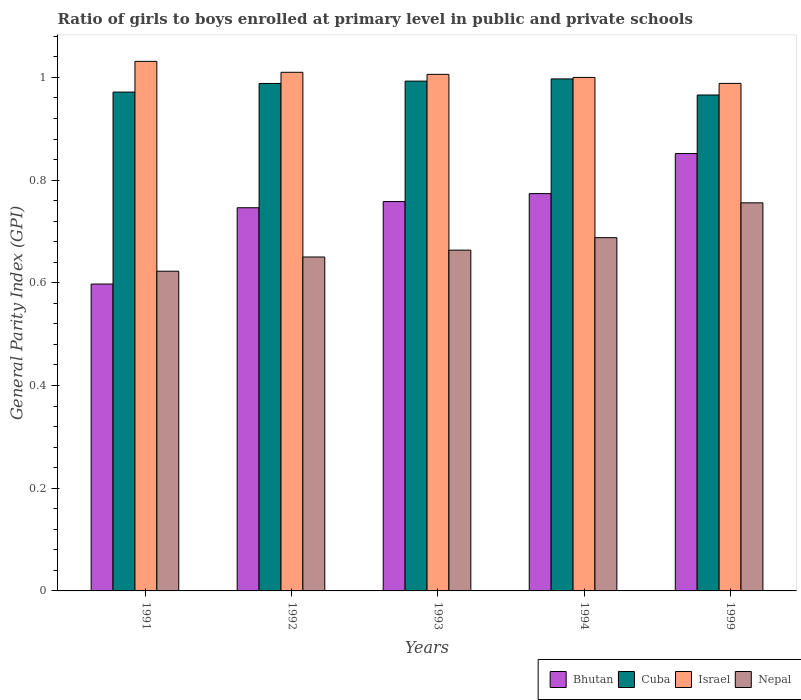How many groups of bars are there?
Your answer should be very brief. 5. Are the number of bars per tick equal to the number of legend labels?
Make the answer very short. Yes. Are the number of bars on each tick of the X-axis equal?
Offer a very short reply. Yes. What is the general parity index in Cuba in 1994?
Offer a very short reply. 1. Across all years, what is the maximum general parity index in Nepal?
Offer a terse response. 0.76. Across all years, what is the minimum general parity index in Nepal?
Provide a succinct answer. 0.62. What is the total general parity index in Nepal in the graph?
Provide a succinct answer. 3.38. What is the difference between the general parity index in Bhutan in 1992 and that in 1993?
Offer a very short reply. -0.01. What is the difference between the general parity index in Israel in 1993 and the general parity index in Nepal in 1994?
Make the answer very short. 0.32. What is the average general parity index in Bhutan per year?
Your response must be concise. 0.75. In the year 1994, what is the difference between the general parity index in Israel and general parity index in Nepal?
Give a very brief answer. 0.31. In how many years, is the general parity index in Israel greater than 0.9600000000000001?
Your answer should be very brief. 5. What is the ratio of the general parity index in Bhutan in 1991 to that in 1994?
Make the answer very short. 0.77. What is the difference between the highest and the second highest general parity index in Nepal?
Offer a very short reply. 0.07. What is the difference between the highest and the lowest general parity index in Israel?
Give a very brief answer. 0.04. In how many years, is the general parity index in Cuba greater than the average general parity index in Cuba taken over all years?
Provide a short and direct response. 3. What does the 4th bar from the left in 1991 represents?
Your answer should be very brief. Nepal. What does the 1st bar from the right in 1991 represents?
Your answer should be very brief. Nepal. Is it the case that in every year, the sum of the general parity index in Cuba and general parity index in Israel is greater than the general parity index in Nepal?
Make the answer very short. Yes. How many bars are there?
Offer a terse response. 20. Are all the bars in the graph horizontal?
Provide a short and direct response. No. How many years are there in the graph?
Keep it short and to the point. 5. Are the values on the major ticks of Y-axis written in scientific E-notation?
Provide a succinct answer. No. Does the graph contain grids?
Provide a short and direct response. No. How many legend labels are there?
Your response must be concise. 4. How are the legend labels stacked?
Give a very brief answer. Horizontal. What is the title of the graph?
Your answer should be very brief. Ratio of girls to boys enrolled at primary level in public and private schools. Does "San Marino" appear as one of the legend labels in the graph?
Offer a terse response. No. What is the label or title of the X-axis?
Offer a terse response. Years. What is the label or title of the Y-axis?
Your answer should be very brief. General Parity Index (GPI). What is the General Parity Index (GPI) of Bhutan in 1991?
Give a very brief answer. 0.6. What is the General Parity Index (GPI) in Cuba in 1991?
Offer a terse response. 0.97. What is the General Parity Index (GPI) in Israel in 1991?
Make the answer very short. 1.03. What is the General Parity Index (GPI) of Nepal in 1991?
Provide a short and direct response. 0.62. What is the General Parity Index (GPI) in Bhutan in 1992?
Provide a short and direct response. 0.75. What is the General Parity Index (GPI) of Cuba in 1992?
Provide a succinct answer. 0.99. What is the General Parity Index (GPI) in Israel in 1992?
Provide a short and direct response. 1.01. What is the General Parity Index (GPI) of Nepal in 1992?
Keep it short and to the point. 0.65. What is the General Parity Index (GPI) in Bhutan in 1993?
Provide a short and direct response. 0.76. What is the General Parity Index (GPI) in Cuba in 1993?
Your answer should be very brief. 0.99. What is the General Parity Index (GPI) in Israel in 1993?
Give a very brief answer. 1.01. What is the General Parity Index (GPI) of Nepal in 1993?
Provide a short and direct response. 0.66. What is the General Parity Index (GPI) of Bhutan in 1994?
Your answer should be very brief. 0.77. What is the General Parity Index (GPI) of Cuba in 1994?
Your answer should be very brief. 1. What is the General Parity Index (GPI) of Israel in 1994?
Ensure brevity in your answer.  1. What is the General Parity Index (GPI) in Nepal in 1994?
Keep it short and to the point. 0.69. What is the General Parity Index (GPI) of Bhutan in 1999?
Make the answer very short. 0.85. What is the General Parity Index (GPI) in Cuba in 1999?
Your answer should be very brief. 0.97. What is the General Parity Index (GPI) of Israel in 1999?
Offer a very short reply. 0.99. What is the General Parity Index (GPI) in Nepal in 1999?
Provide a succinct answer. 0.76. Across all years, what is the maximum General Parity Index (GPI) in Bhutan?
Keep it short and to the point. 0.85. Across all years, what is the maximum General Parity Index (GPI) in Cuba?
Keep it short and to the point. 1. Across all years, what is the maximum General Parity Index (GPI) in Israel?
Provide a succinct answer. 1.03. Across all years, what is the maximum General Parity Index (GPI) in Nepal?
Your answer should be compact. 0.76. Across all years, what is the minimum General Parity Index (GPI) of Bhutan?
Offer a terse response. 0.6. Across all years, what is the minimum General Parity Index (GPI) in Cuba?
Offer a terse response. 0.97. Across all years, what is the minimum General Parity Index (GPI) of Israel?
Offer a very short reply. 0.99. Across all years, what is the minimum General Parity Index (GPI) of Nepal?
Provide a short and direct response. 0.62. What is the total General Parity Index (GPI) of Bhutan in the graph?
Keep it short and to the point. 3.73. What is the total General Parity Index (GPI) of Cuba in the graph?
Keep it short and to the point. 4.91. What is the total General Parity Index (GPI) of Israel in the graph?
Offer a very short reply. 5.04. What is the total General Parity Index (GPI) in Nepal in the graph?
Your response must be concise. 3.38. What is the difference between the General Parity Index (GPI) of Bhutan in 1991 and that in 1992?
Offer a terse response. -0.15. What is the difference between the General Parity Index (GPI) of Cuba in 1991 and that in 1992?
Offer a terse response. -0.02. What is the difference between the General Parity Index (GPI) of Israel in 1991 and that in 1992?
Your response must be concise. 0.02. What is the difference between the General Parity Index (GPI) in Nepal in 1991 and that in 1992?
Your answer should be compact. -0.03. What is the difference between the General Parity Index (GPI) in Bhutan in 1991 and that in 1993?
Keep it short and to the point. -0.16. What is the difference between the General Parity Index (GPI) in Cuba in 1991 and that in 1993?
Your response must be concise. -0.02. What is the difference between the General Parity Index (GPI) in Israel in 1991 and that in 1993?
Offer a very short reply. 0.03. What is the difference between the General Parity Index (GPI) in Nepal in 1991 and that in 1993?
Your answer should be compact. -0.04. What is the difference between the General Parity Index (GPI) of Bhutan in 1991 and that in 1994?
Offer a very short reply. -0.18. What is the difference between the General Parity Index (GPI) in Cuba in 1991 and that in 1994?
Provide a succinct answer. -0.03. What is the difference between the General Parity Index (GPI) in Israel in 1991 and that in 1994?
Provide a short and direct response. 0.03. What is the difference between the General Parity Index (GPI) of Nepal in 1991 and that in 1994?
Ensure brevity in your answer.  -0.07. What is the difference between the General Parity Index (GPI) in Bhutan in 1991 and that in 1999?
Your answer should be compact. -0.25. What is the difference between the General Parity Index (GPI) of Cuba in 1991 and that in 1999?
Ensure brevity in your answer.  0.01. What is the difference between the General Parity Index (GPI) of Israel in 1991 and that in 1999?
Provide a short and direct response. 0.04. What is the difference between the General Parity Index (GPI) in Nepal in 1991 and that in 1999?
Provide a short and direct response. -0.13. What is the difference between the General Parity Index (GPI) in Bhutan in 1992 and that in 1993?
Your response must be concise. -0.01. What is the difference between the General Parity Index (GPI) of Cuba in 1992 and that in 1993?
Make the answer very short. -0. What is the difference between the General Parity Index (GPI) in Israel in 1992 and that in 1993?
Your answer should be compact. 0. What is the difference between the General Parity Index (GPI) in Nepal in 1992 and that in 1993?
Give a very brief answer. -0.01. What is the difference between the General Parity Index (GPI) in Bhutan in 1992 and that in 1994?
Provide a succinct answer. -0.03. What is the difference between the General Parity Index (GPI) in Cuba in 1992 and that in 1994?
Your answer should be very brief. -0.01. What is the difference between the General Parity Index (GPI) in Israel in 1992 and that in 1994?
Make the answer very short. 0.01. What is the difference between the General Parity Index (GPI) in Nepal in 1992 and that in 1994?
Your response must be concise. -0.04. What is the difference between the General Parity Index (GPI) of Bhutan in 1992 and that in 1999?
Your response must be concise. -0.11. What is the difference between the General Parity Index (GPI) in Cuba in 1992 and that in 1999?
Your answer should be compact. 0.02. What is the difference between the General Parity Index (GPI) in Israel in 1992 and that in 1999?
Your response must be concise. 0.02. What is the difference between the General Parity Index (GPI) of Nepal in 1992 and that in 1999?
Make the answer very short. -0.11. What is the difference between the General Parity Index (GPI) in Bhutan in 1993 and that in 1994?
Make the answer very short. -0.02. What is the difference between the General Parity Index (GPI) in Cuba in 1993 and that in 1994?
Keep it short and to the point. -0. What is the difference between the General Parity Index (GPI) in Israel in 1993 and that in 1994?
Your response must be concise. 0.01. What is the difference between the General Parity Index (GPI) of Nepal in 1993 and that in 1994?
Your response must be concise. -0.02. What is the difference between the General Parity Index (GPI) of Bhutan in 1993 and that in 1999?
Your answer should be very brief. -0.09. What is the difference between the General Parity Index (GPI) of Cuba in 1993 and that in 1999?
Provide a short and direct response. 0.03. What is the difference between the General Parity Index (GPI) of Israel in 1993 and that in 1999?
Provide a short and direct response. 0.02. What is the difference between the General Parity Index (GPI) in Nepal in 1993 and that in 1999?
Offer a very short reply. -0.09. What is the difference between the General Parity Index (GPI) of Bhutan in 1994 and that in 1999?
Keep it short and to the point. -0.08. What is the difference between the General Parity Index (GPI) of Cuba in 1994 and that in 1999?
Your answer should be very brief. 0.03. What is the difference between the General Parity Index (GPI) of Israel in 1994 and that in 1999?
Your answer should be very brief. 0.01. What is the difference between the General Parity Index (GPI) in Nepal in 1994 and that in 1999?
Provide a short and direct response. -0.07. What is the difference between the General Parity Index (GPI) in Bhutan in 1991 and the General Parity Index (GPI) in Cuba in 1992?
Offer a terse response. -0.39. What is the difference between the General Parity Index (GPI) in Bhutan in 1991 and the General Parity Index (GPI) in Israel in 1992?
Your answer should be compact. -0.41. What is the difference between the General Parity Index (GPI) of Bhutan in 1991 and the General Parity Index (GPI) of Nepal in 1992?
Make the answer very short. -0.05. What is the difference between the General Parity Index (GPI) of Cuba in 1991 and the General Parity Index (GPI) of Israel in 1992?
Keep it short and to the point. -0.04. What is the difference between the General Parity Index (GPI) in Cuba in 1991 and the General Parity Index (GPI) in Nepal in 1992?
Your answer should be compact. 0.32. What is the difference between the General Parity Index (GPI) in Israel in 1991 and the General Parity Index (GPI) in Nepal in 1992?
Your response must be concise. 0.38. What is the difference between the General Parity Index (GPI) in Bhutan in 1991 and the General Parity Index (GPI) in Cuba in 1993?
Keep it short and to the point. -0.4. What is the difference between the General Parity Index (GPI) in Bhutan in 1991 and the General Parity Index (GPI) in Israel in 1993?
Ensure brevity in your answer.  -0.41. What is the difference between the General Parity Index (GPI) of Bhutan in 1991 and the General Parity Index (GPI) of Nepal in 1993?
Offer a very short reply. -0.07. What is the difference between the General Parity Index (GPI) in Cuba in 1991 and the General Parity Index (GPI) in Israel in 1993?
Give a very brief answer. -0.03. What is the difference between the General Parity Index (GPI) of Cuba in 1991 and the General Parity Index (GPI) of Nepal in 1993?
Provide a short and direct response. 0.31. What is the difference between the General Parity Index (GPI) in Israel in 1991 and the General Parity Index (GPI) in Nepal in 1993?
Offer a very short reply. 0.37. What is the difference between the General Parity Index (GPI) of Bhutan in 1991 and the General Parity Index (GPI) of Cuba in 1994?
Your answer should be very brief. -0.4. What is the difference between the General Parity Index (GPI) in Bhutan in 1991 and the General Parity Index (GPI) in Israel in 1994?
Your response must be concise. -0.4. What is the difference between the General Parity Index (GPI) of Bhutan in 1991 and the General Parity Index (GPI) of Nepal in 1994?
Provide a succinct answer. -0.09. What is the difference between the General Parity Index (GPI) of Cuba in 1991 and the General Parity Index (GPI) of Israel in 1994?
Provide a succinct answer. -0.03. What is the difference between the General Parity Index (GPI) in Cuba in 1991 and the General Parity Index (GPI) in Nepal in 1994?
Provide a succinct answer. 0.28. What is the difference between the General Parity Index (GPI) of Israel in 1991 and the General Parity Index (GPI) of Nepal in 1994?
Your response must be concise. 0.34. What is the difference between the General Parity Index (GPI) in Bhutan in 1991 and the General Parity Index (GPI) in Cuba in 1999?
Keep it short and to the point. -0.37. What is the difference between the General Parity Index (GPI) of Bhutan in 1991 and the General Parity Index (GPI) of Israel in 1999?
Provide a succinct answer. -0.39. What is the difference between the General Parity Index (GPI) of Bhutan in 1991 and the General Parity Index (GPI) of Nepal in 1999?
Make the answer very short. -0.16. What is the difference between the General Parity Index (GPI) of Cuba in 1991 and the General Parity Index (GPI) of Israel in 1999?
Provide a succinct answer. -0.02. What is the difference between the General Parity Index (GPI) of Cuba in 1991 and the General Parity Index (GPI) of Nepal in 1999?
Your answer should be very brief. 0.22. What is the difference between the General Parity Index (GPI) in Israel in 1991 and the General Parity Index (GPI) in Nepal in 1999?
Offer a very short reply. 0.28. What is the difference between the General Parity Index (GPI) of Bhutan in 1992 and the General Parity Index (GPI) of Cuba in 1993?
Provide a succinct answer. -0.25. What is the difference between the General Parity Index (GPI) in Bhutan in 1992 and the General Parity Index (GPI) in Israel in 1993?
Offer a very short reply. -0.26. What is the difference between the General Parity Index (GPI) in Bhutan in 1992 and the General Parity Index (GPI) in Nepal in 1993?
Offer a terse response. 0.08. What is the difference between the General Parity Index (GPI) of Cuba in 1992 and the General Parity Index (GPI) of Israel in 1993?
Your answer should be very brief. -0.02. What is the difference between the General Parity Index (GPI) of Cuba in 1992 and the General Parity Index (GPI) of Nepal in 1993?
Ensure brevity in your answer.  0.32. What is the difference between the General Parity Index (GPI) in Israel in 1992 and the General Parity Index (GPI) in Nepal in 1993?
Make the answer very short. 0.35. What is the difference between the General Parity Index (GPI) of Bhutan in 1992 and the General Parity Index (GPI) of Cuba in 1994?
Your answer should be compact. -0.25. What is the difference between the General Parity Index (GPI) in Bhutan in 1992 and the General Parity Index (GPI) in Israel in 1994?
Provide a short and direct response. -0.25. What is the difference between the General Parity Index (GPI) of Bhutan in 1992 and the General Parity Index (GPI) of Nepal in 1994?
Make the answer very short. 0.06. What is the difference between the General Parity Index (GPI) of Cuba in 1992 and the General Parity Index (GPI) of Israel in 1994?
Your answer should be compact. -0.01. What is the difference between the General Parity Index (GPI) of Cuba in 1992 and the General Parity Index (GPI) of Nepal in 1994?
Offer a very short reply. 0.3. What is the difference between the General Parity Index (GPI) of Israel in 1992 and the General Parity Index (GPI) of Nepal in 1994?
Make the answer very short. 0.32. What is the difference between the General Parity Index (GPI) in Bhutan in 1992 and the General Parity Index (GPI) in Cuba in 1999?
Your answer should be very brief. -0.22. What is the difference between the General Parity Index (GPI) in Bhutan in 1992 and the General Parity Index (GPI) in Israel in 1999?
Your answer should be very brief. -0.24. What is the difference between the General Parity Index (GPI) in Bhutan in 1992 and the General Parity Index (GPI) in Nepal in 1999?
Your answer should be compact. -0.01. What is the difference between the General Parity Index (GPI) in Cuba in 1992 and the General Parity Index (GPI) in Israel in 1999?
Give a very brief answer. -0. What is the difference between the General Parity Index (GPI) in Cuba in 1992 and the General Parity Index (GPI) in Nepal in 1999?
Your response must be concise. 0.23. What is the difference between the General Parity Index (GPI) of Israel in 1992 and the General Parity Index (GPI) of Nepal in 1999?
Make the answer very short. 0.25. What is the difference between the General Parity Index (GPI) in Bhutan in 1993 and the General Parity Index (GPI) in Cuba in 1994?
Keep it short and to the point. -0.24. What is the difference between the General Parity Index (GPI) in Bhutan in 1993 and the General Parity Index (GPI) in Israel in 1994?
Make the answer very short. -0.24. What is the difference between the General Parity Index (GPI) of Bhutan in 1993 and the General Parity Index (GPI) of Nepal in 1994?
Your response must be concise. 0.07. What is the difference between the General Parity Index (GPI) of Cuba in 1993 and the General Parity Index (GPI) of Israel in 1994?
Offer a terse response. -0.01. What is the difference between the General Parity Index (GPI) of Cuba in 1993 and the General Parity Index (GPI) of Nepal in 1994?
Provide a succinct answer. 0.3. What is the difference between the General Parity Index (GPI) in Israel in 1993 and the General Parity Index (GPI) in Nepal in 1994?
Give a very brief answer. 0.32. What is the difference between the General Parity Index (GPI) of Bhutan in 1993 and the General Parity Index (GPI) of Cuba in 1999?
Provide a short and direct response. -0.21. What is the difference between the General Parity Index (GPI) of Bhutan in 1993 and the General Parity Index (GPI) of Israel in 1999?
Keep it short and to the point. -0.23. What is the difference between the General Parity Index (GPI) of Bhutan in 1993 and the General Parity Index (GPI) of Nepal in 1999?
Provide a short and direct response. 0. What is the difference between the General Parity Index (GPI) in Cuba in 1993 and the General Parity Index (GPI) in Israel in 1999?
Provide a succinct answer. 0. What is the difference between the General Parity Index (GPI) in Cuba in 1993 and the General Parity Index (GPI) in Nepal in 1999?
Your response must be concise. 0.24. What is the difference between the General Parity Index (GPI) in Israel in 1993 and the General Parity Index (GPI) in Nepal in 1999?
Your answer should be compact. 0.25. What is the difference between the General Parity Index (GPI) of Bhutan in 1994 and the General Parity Index (GPI) of Cuba in 1999?
Give a very brief answer. -0.19. What is the difference between the General Parity Index (GPI) of Bhutan in 1994 and the General Parity Index (GPI) of Israel in 1999?
Provide a short and direct response. -0.21. What is the difference between the General Parity Index (GPI) in Bhutan in 1994 and the General Parity Index (GPI) in Nepal in 1999?
Your answer should be compact. 0.02. What is the difference between the General Parity Index (GPI) in Cuba in 1994 and the General Parity Index (GPI) in Israel in 1999?
Provide a short and direct response. 0.01. What is the difference between the General Parity Index (GPI) of Cuba in 1994 and the General Parity Index (GPI) of Nepal in 1999?
Make the answer very short. 0.24. What is the difference between the General Parity Index (GPI) of Israel in 1994 and the General Parity Index (GPI) of Nepal in 1999?
Give a very brief answer. 0.24. What is the average General Parity Index (GPI) of Bhutan per year?
Give a very brief answer. 0.75. What is the average General Parity Index (GPI) in Nepal per year?
Provide a short and direct response. 0.68. In the year 1991, what is the difference between the General Parity Index (GPI) in Bhutan and General Parity Index (GPI) in Cuba?
Keep it short and to the point. -0.37. In the year 1991, what is the difference between the General Parity Index (GPI) in Bhutan and General Parity Index (GPI) in Israel?
Make the answer very short. -0.43. In the year 1991, what is the difference between the General Parity Index (GPI) of Bhutan and General Parity Index (GPI) of Nepal?
Keep it short and to the point. -0.03. In the year 1991, what is the difference between the General Parity Index (GPI) of Cuba and General Parity Index (GPI) of Israel?
Offer a terse response. -0.06. In the year 1991, what is the difference between the General Parity Index (GPI) of Cuba and General Parity Index (GPI) of Nepal?
Your answer should be very brief. 0.35. In the year 1991, what is the difference between the General Parity Index (GPI) of Israel and General Parity Index (GPI) of Nepal?
Make the answer very short. 0.41. In the year 1992, what is the difference between the General Parity Index (GPI) of Bhutan and General Parity Index (GPI) of Cuba?
Make the answer very short. -0.24. In the year 1992, what is the difference between the General Parity Index (GPI) in Bhutan and General Parity Index (GPI) in Israel?
Make the answer very short. -0.26. In the year 1992, what is the difference between the General Parity Index (GPI) of Bhutan and General Parity Index (GPI) of Nepal?
Your response must be concise. 0.1. In the year 1992, what is the difference between the General Parity Index (GPI) in Cuba and General Parity Index (GPI) in Israel?
Provide a short and direct response. -0.02. In the year 1992, what is the difference between the General Parity Index (GPI) of Cuba and General Parity Index (GPI) of Nepal?
Your response must be concise. 0.34. In the year 1992, what is the difference between the General Parity Index (GPI) of Israel and General Parity Index (GPI) of Nepal?
Keep it short and to the point. 0.36. In the year 1993, what is the difference between the General Parity Index (GPI) in Bhutan and General Parity Index (GPI) in Cuba?
Your answer should be very brief. -0.23. In the year 1993, what is the difference between the General Parity Index (GPI) in Bhutan and General Parity Index (GPI) in Israel?
Offer a terse response. -0.25. In the year 1993, what is the difference between the General Parity Index (GPI) in Bhutan and General Parity Index (GPI) in Nepal?
Provide a short and direct response. 0.09. In the year 1993, what is the difference between the General Parity Index (GPI) of Cuba and General Parity Index (GPI) of Israel?
Your answer should be compact. -0.01. In the year 1993, what is the difference between the General Parity Index (GPI) in Cuba and General Parity Index (GPI) in Nepal?
Provide a succinct answer. 0.33. In the year 1993, what is the difference between the General Parity Index (GPI) in Israel and General Parity Index (GPI) in Nepal?
Your response must be concise. 0.34. In the year 1994, what is the difference between the General Parity Index (GPI) in Bhutan and General Parity Index (GPI) in Cuba?
Make the answer very short. -0.22. In the year 1994, what is the difference between the General Parity Index (GPI) in Bhutan and General Parity Index (GPI) in Israel?
Give a very brief answer. -0.23. In the year 1994, what is the difference between the General Parity Index (GPI) in Bhutan and General Parity Index (GPI) in Nepal?
Provide a succinct answer. 0.09. In the year 1994, what is the difference between the General Parity Index (GPI) in Cuba and General Parity Index (GPI) in Israel?
Offer a very short reply. -0. In the year 1994, what is the difference between the General Parity Index (GPI) in Cuba and General Parity Index (GPI) in Nepal?
Make the answer very short. 0.31. In the year 1994, what is the difference between the General Parity Index (GPI) in Israel and General Parity Index (GPI) in Nepal?
Give a very brief answer. 0.31. In the year 1999, what is the difference between the General Parity Index (GPI) of Bhutan and General Parity Index (GPI) of Cuba?
Your answer should be compact. -0.11. In the year 1999, what is the difference between the General Parity Index (GPI) of Bhutan and General Parity Index (GPI) of Israel?
Your answer should be very brief. -0.14. In the year 1999, what is the difference between the General Parity Index (GPI) of Bhutan and General Parity Index (GPI) of Nepal?
Your answer should be very brief. 0.1. In the year 1999, what is the difference between the General Parity Index (GPI) in Cuba and General Parity Index (GPI) in Israel?
Provide a succinct answer. -0.02. In the year 1999, what is the difference between the General Parity Index (GPI) in Cuba and General Parity Index (GPI) in Nepal?
Provide a short and direct response. 0.21. In the year 1999, what is the difference between the General Parity Index (GPI) of Israel and General Parity Index (GPI) of Nepal?
Provide a succinct answer. 0.23. What is the ratio of the General Parity Index (GPI) of Bhutan in 1991 to that in 1992?
Keep it short and to the point. 0.8. What is the ratio of the General Parity Index (GPI) in Cuba in 1991 to that in 1992?
Keep it short and to the point. 0.98. What is the ratio of the General Parity Index (GPI) in Israel in 1991 to that in 1992?
Provide a succinct answer. 1.02. What is the ratio of the General Parity Index (GPI) in Nepal in 1991 to that in 1992?
Offer a terse response. 0.96. What is the ratio of the General Parity Index (GPI) of Bhutan in 1991 to that in 1993?
Offer a very short reply. 0.79. What is the ratio of the General Parity Index (GPI) in Cuba in 1991 to that in 1993?
Make the answer very short. 0.98. What is the ratio of the General Parity Index (GPI) in Israel in 1991 to that in 1993?
Ensure brevity in your answer.  1.03. What is the ratio of the General Parity Index (GPI) of Nepal in 1991 to that in 1993?
Offer a terse response. 0.94. What is the ratio of the General Parity Index (GPI) in Bhutan in 1991 to that in 1994?
Provide a succinct answer. 0.77. What is the ratio of the General Parity Index (GPI) of Cuba in 1991 to that in 1994?
Offer a terse response. 0.97. What is the ratio of the General Parity Index (GPI) in Israel in 1991 to that in 1994?
Your answer should be compact. 1.03. What is the ratio of the General Parity Index (GPI) in Nepal in 1991 to that in 1994?
Offer a very short reply. 0.91. What is the ratio of the General Parity Index (GPI) of Bhutan in 1991 to that in 1999?
Offer a terse response. 0.7. What is the ratio of the General Parity Index (GPI) of Cuba in 1991 to that in 1999?
Offer a terse response. 1.01. What is the ratio of the General Parity Index (GPI) in Israel in 1991 to that in 1999?
Your answer should be very brief. 1.04. What is the ratio of the General Parity Index (GPI) in Nepal in 1991 to that in 1999?
Offer a very short reply. 0.82. What is the ratio of the General Parity Index (GPI) of Bhutan in 1992 to that in 1993?
Offer a terse response. 0.98. What is the ratio of the General Parity Index (GPI) of Nepal in 1992 to that in 1993?
Offer a terse response. 0.98. What is the ratio of the General Parity Index (GPI) in Bhutan in 1992 to that in 1994?
Offer a terse response. 0.96. What is the ratio of the General Parity Index (GPI) in Cuba in 1992 to that in 1994?
Your response must be concise. 0.99. What is the ratio of the General Parity Index (GPI) in Israel in 1992 to that in 1994?
Offer a terse response. 1.01. What is the ratio of the General Parity Index (GPI) of Nepal in 1992 to that in 1994?
Ensure brevity in your answer.  0.95. What is the ratio of the General Parity Index (GPI) of Bhutan in 1992 to that in 1999?
Give a very brief answer. 0.88. What is the ratio of the General Parity Index (GPI) in Cuba in 1992 to that in 1999?
Keep it short and to the point. 1.02. What is the ratio of the General Parity Index (GPI) in Israel in 1992 to that in 1999?
Provide a succinct answer. 1.02. What is the ratio of the General Parity Index (GPI) of Nepal in 1992 to that in 1999?
Your response must be concise. 0.86. What is the ratio of the General Parity Index (GPI) of Bhutan in 1993 to that in 1994?
Ensure brevity in your answer.  0.98. What is the ratio of the General Parity Index (GPI) of Nepal in 1993 to that in 1994?
Make the answer very short. 0.96. What is the ratio of the General Parity Index (GPI) of Bhutan in 1993 to that in 1999?
Your answer should be compact. 0.89. What is the ratio of the General Parity Index (GPI) of Cuba in 1993 to that in 1999?
Your answer should be very brief. 1.03. What is the ratio of the General Parity Index (GPI) of Israel in 1993 to that in 1999?
Provide a short and direct response. 1.02. What is the ratio of the General Parity Index (GPI) of Nepal in 1993 to that in 1999?
Your answer should be compact. 0.88. What is the ratio of the General Parity Index (GPI) of Bhutan in 1994 to that in 1999?
Your response must be concise. 0.91. What is the ratio of the General Parity Index (GPI) in Cuba in 1994 to that in 1999?
Give a very brief answer. 1.03. What is the ratio of the General Parity Index (GPI) in Israel in 1994 to that in 1999?
Give a very brief answer. 1.01. What is the ratio of the General Parity Index (GPI) in Nepal in 1994 to that in 1999?
Your answer should be very brief. 0.91. What is the difference between the highest and the second highest General Parity Index (GPI) of Bhutan?
Your answer should be compact. 0.08. What is the difference between the highest and the second highest General Parity Index (GPI) of Cuba?
Give a very brief answer. 0. What is the difference between the highest and the second highest General Parity Index (GPI) of Israel?
Your answer should be compact. 0.02. What is the difference between the highest and the second highest General Parity Index (GPI) in Nepal?
Your response must be concise. 0.07. What is the difference between the highest and the lowest General Parity Index (GPI) of Bhutan?
Provide a short and direct response. 0.25. What is the difference between the highest and the lowest General Parity Index (GPI) in Cuba?
Give a very brief answer. 0.03. What is the difference between the highest and the lowest General Parity Index (GPI) in Israel?
Give a very brief answer. 0.04. What is the difference between the highest and the lowest General Parity Index (GPI) of Nepal?
Offer a terse response. 0.13. 